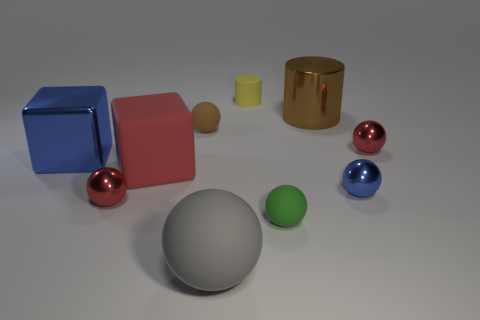Subtract 3 balls. How many balls are left? 3 Subtract all red spheres. How many spheres are left? 4 Subtract all gray rubber balls. How many balls are left? 5 Subtract all yellow balls. Subtract all blue cylinders. How many balls are left? 6 Subtract all blocks. How many objects are left? 8 Subtract all matte spheres. Subtract all big purple shiny cubes. How many objects are left? 7 Add 5 red cubes. How many red cubes are left? 6 Add 5 tiny gray matte blocks. How many tiny gray matte blocks exist? 5 Subtract 0 cyan cylinders. How many objects are left? 10 